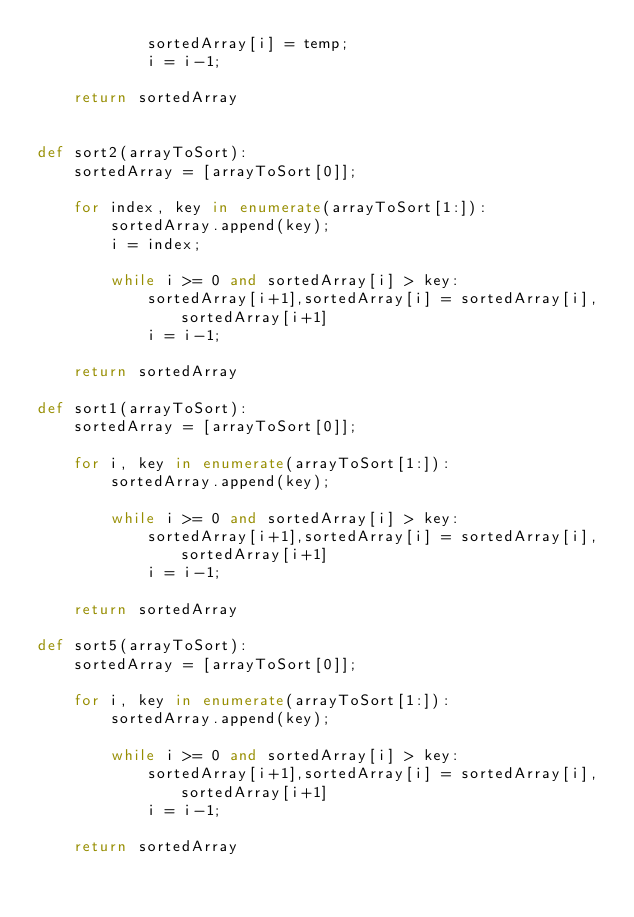Convert code to text. <code><loc_0><loc_0><loc_500><loc_500><_Python_>            sortedArray[i] = temp;
            i = i-1;
        
    return sortedArray


def sort2(arrayToSort):
    sortedArray = [arrayToSort[0]];

    for index, key in enumerate(arrayToSort[1:]):
        sortedArray.append(key);  
        i = index; 

        while i >= 0 and sortedArray[i] > key:
            sortedArray[i+1],sortedArray[i] = sortedArray[i],sortedArray[i+1]
            i = i-1;
        
    return sortedArray

def sort1(arrayToSort):
    sortedArray = [arrayToSort[0]];

    for i, key in enumerate(arrayToSort[1:]):
        sortedArray.append(key);  

        while i >= 0 and sortedArray[i] > key:
            sortedArray[i+1],sortedArray[i] = sortedArray[i],sortedArray[i+1]
            i = i-1;
        
    return sortedArray

def sort5(arrayToSort):
    sortedArray = [arrayToSort[0]];

    for i, key in enumerate(arrayToSort[1:]):
        sortedArray.append(key);  

        while i >= 0 and sortedArray[i] > key:
            sortedArray[i+1],sortedArray[i] = sortedArray[i],sortedArray[i+1]
            i = i-1;
        
    return sortedArray
</code> 